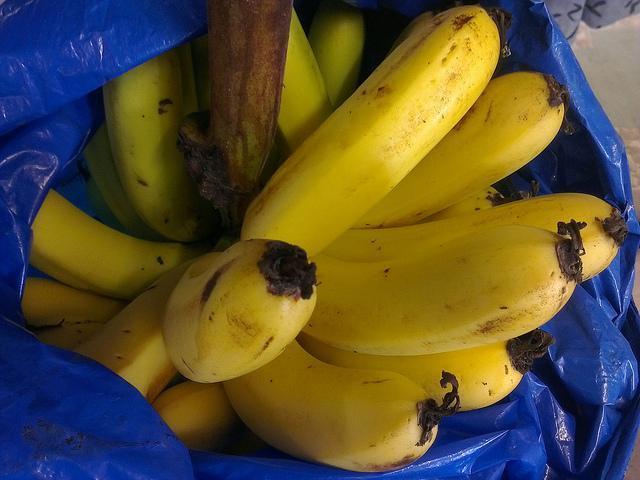How many bananas are in the picture?
Give a very brief answer. 2. How many people are up on the hill?
Give a very brief answer. 0. 